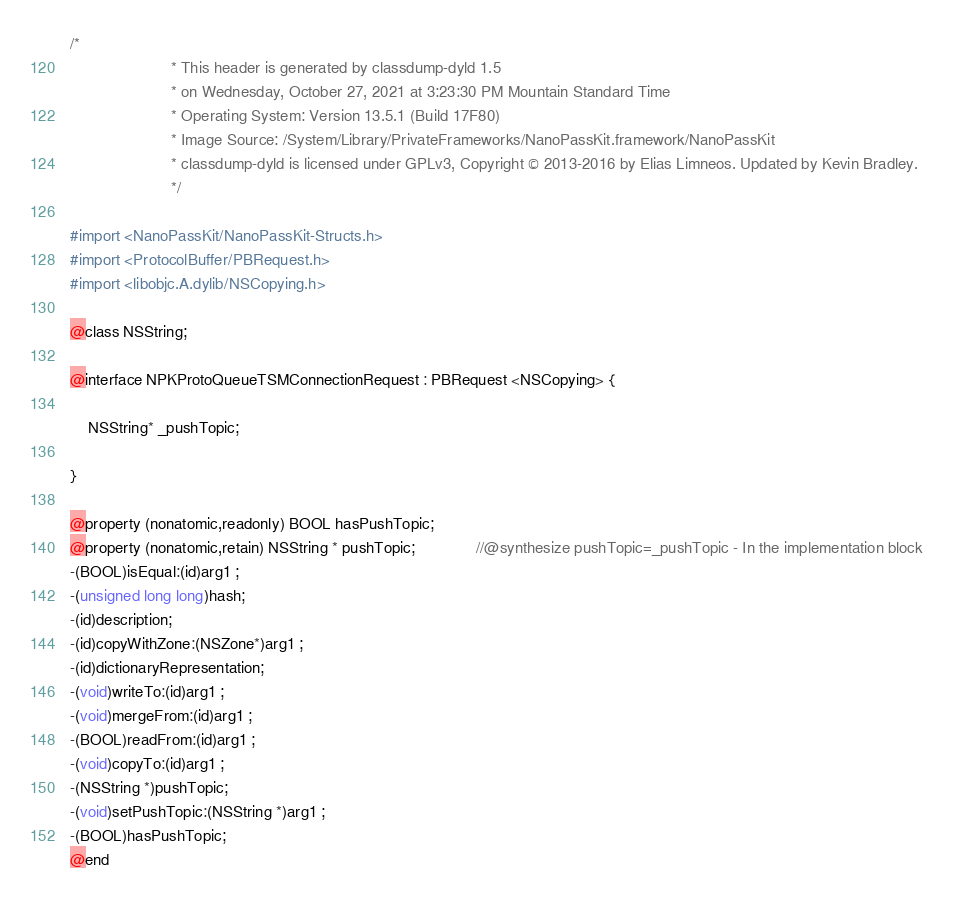<code> <loc_0><loc_0><loc_500><loc_500><_C_>/*
                       * This header is generated by classdump-dyld 1.5
                       * on Wednesday, October 27, 2021 at 3:23:30 PM Mountain Standard Time
                       * Operating System: Version 13.5.1 (Build 17F80)
                       * Image Source: /System/Library/PrivateFrameworks/NanoPassKit.framework/NanoPassKit
                       * classdump-dyld is licensed under GPLv3, Copyright © 2013-2016 by Elias Limneos. Updated by Kevin Bradley.
                       */

#import <NanoPassKit/NanoPassKit-Structs.h>
#import <ProtocolBuffer/PBRequest.h>
#import <libobjc.A.dylib/NSCopying.h>

@class NSString;

@interface NPKProtoQueueTSMConnectionRequest : PBRequest <NSCopying> {

	NSString* _pushTopic;

}

@property (nonatomic,readonly) BOOL hasPushTopic; 
@property (nonatomic,retain) NSString * pushTopic;              //@synthesize pushTopic=_pushTopic - In the implementation block
-(BOOL)isEqual:(id)arg1 ;
-(unsigned long long)hash;
-(id)description;
-(id)copyWithZone:(NSZone*)arg1 ;
-(id)dictionaryRepresentation;
-(void)writeTo:(id)arg1 ;
-(void)mergeFrom:(id)arg1 ;
-(BOOL)readFrom:(id)arg1 ;
-(void)copyTo:(id)arg1 ;
-(NSString *)pushTopic;
-(void)setPushTopic:(NSString *)arg1 ;
-(BOOL)hasPushTopic;
@end

</code> 